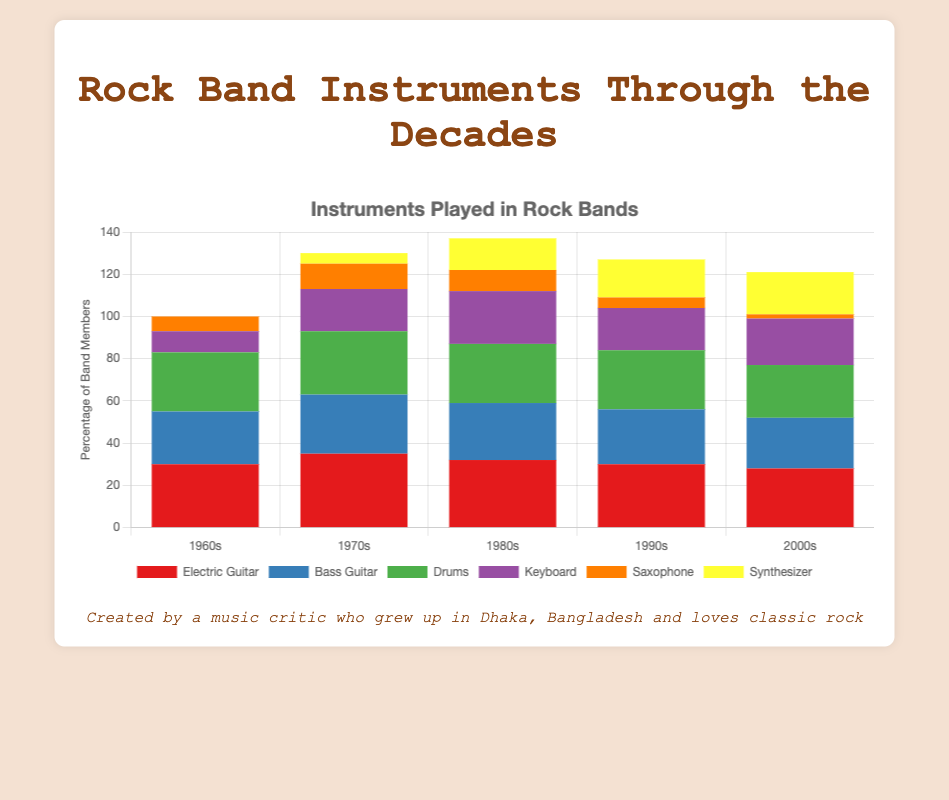Which decade saw the highest use of the Electric Guitar? By examining the heights of the red bars representing Electric Guitar in each decade, we can see that the highest usage occurs in the 1970s.
Answer: 1970s Which instrument saw a steady increase in usage from the 1960s to the 2000s? Observing the stacked bars, the Synthesizer bars (yellow) show a steady increase from 0 in the 1960s to 20 in the 2000s.
Answer: Synthesizer In which decade did the usage of the Saxophone drastically decline? By comparing the orange Saxophone bars, there's a significant drop between the 1980s and the 1990s.
Answer: 1990s How many more percentage points was the Keyboard played in the 1980s compared to the 1960s? The height of the purple Keyboard bars indicates 25 in the 1980s and 10 in the 1960s. The difference is 25 - 10 = 15.
Answer: 15 Between the 1970s and the 2000s, did the usage of the Bass Guitar increase, decrease, or stay the same? The heights of the blue Bass Guitar bars show 28 in the 1970s and 24 in the 2000s, indicating a decrease.
Answer: Decrease What instrument was introduced in the 1970s and saw an upward trend in subsequent decades? The Synthesizer appears from the 1970s bar onwards and continues to increase through the subsequent decades.
Answer: Synthesizer What is the sum of the percentages for the Drums and Keyboard in the 1990s? In the 1990s, Drums are at 28 and Keyboard at 20. The sum is 28 + 20 = 48.
Answer: 48 Which instrument had the lowest usage in the 2000s? By examining the stacked bars, the orange Saxophone bar is the smallest in the 2000s with a value of 2.
Answer: Saxophone Compare the usage of Electric Guitar and Bass Guitar in the 1980s. Which one was more prevalent and by how much? The Electric Guitar is at 32, and the Bass Guitar is at 27 in the 1980s. The difference is 32 - 27 = 5, indicating that the Electric Guitar was used more.
Answer: Electric Guitar, 5 Identify the decade where the total usage of Keyboard and Synthesizer combined was highest. Adding the values of purple and yellow bars for each decade: 1960s: 10 + 0 = 10, 1970s: 20 + 5 = 25, 1980s: 25 + 15 = 40, 1990s: 20 + 18 = 38, 2000s: 22 + 20 = 42. The highest is 42 in the 2000s.
Answer: 2000s 